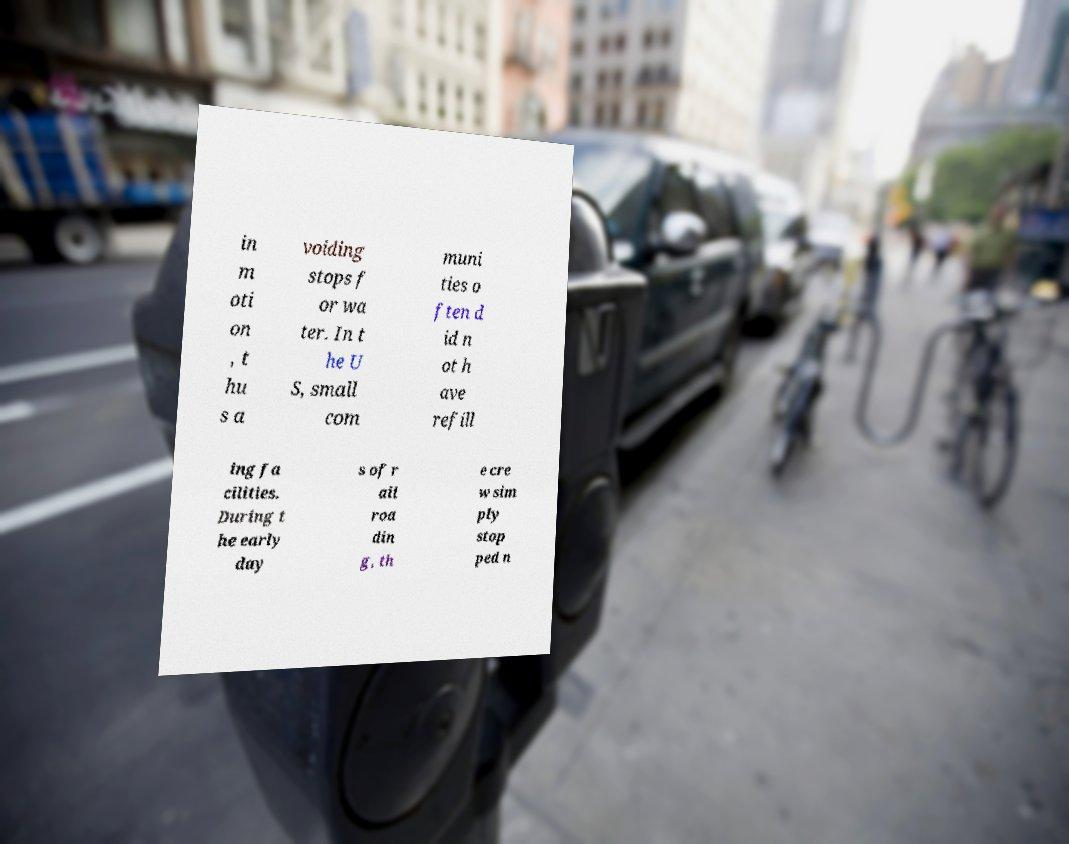Please identify and transcribe the text found in this image. in m oti on , t hu s a voiding stops f or wa ter. In t he U S, small com muni ties o ften d id n ot h ave refill ing fa cilities. During t he early day s of r ail roa din g, th e cre w sim ply stop ped n 